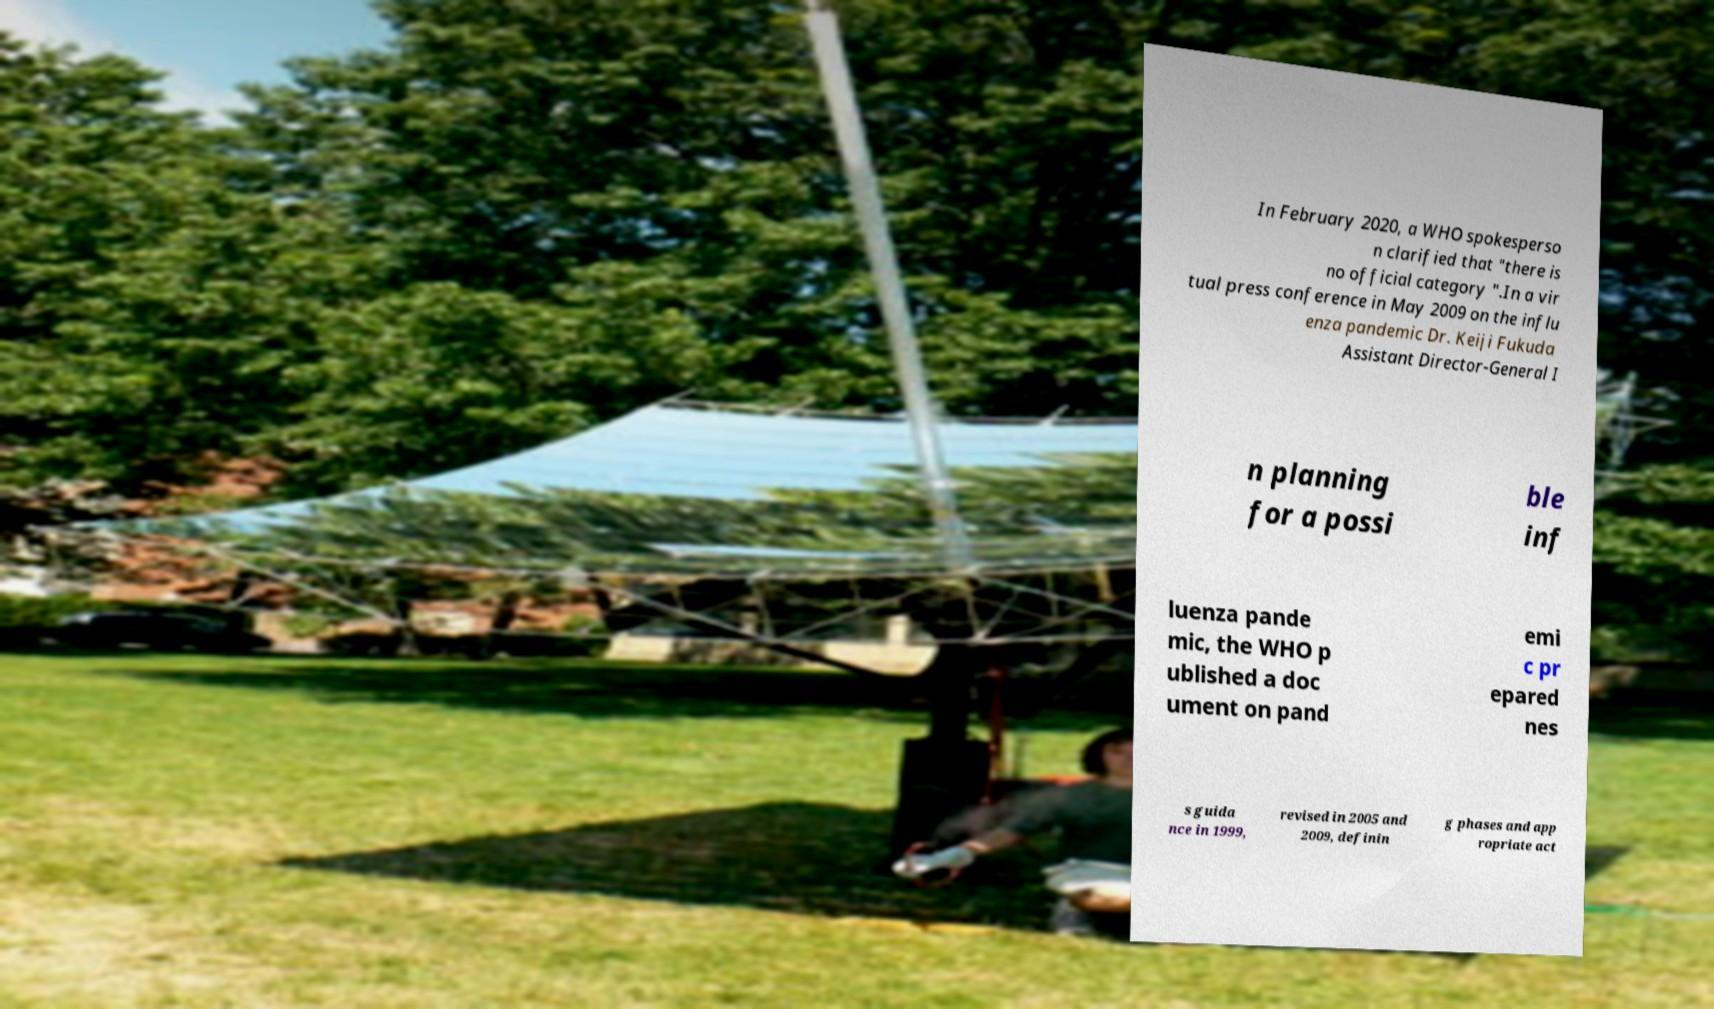What messages or text are displayed in this image? I need them in a readable, typed format. In February 2020, a WHO spokesperso n clarified that "there is no official category ".In a vir tual press conference in May 2009 on the influ enza pandemic Dr. Keiji Fukuda Assistant Director-General I n planning for a possi ble inf luenza pande mic, the WHO p ublished a doc ument on pand emi c pr epared nes s guida nce in 1999, revised in 2005 and 2009, definin g phases and app ropriate act 